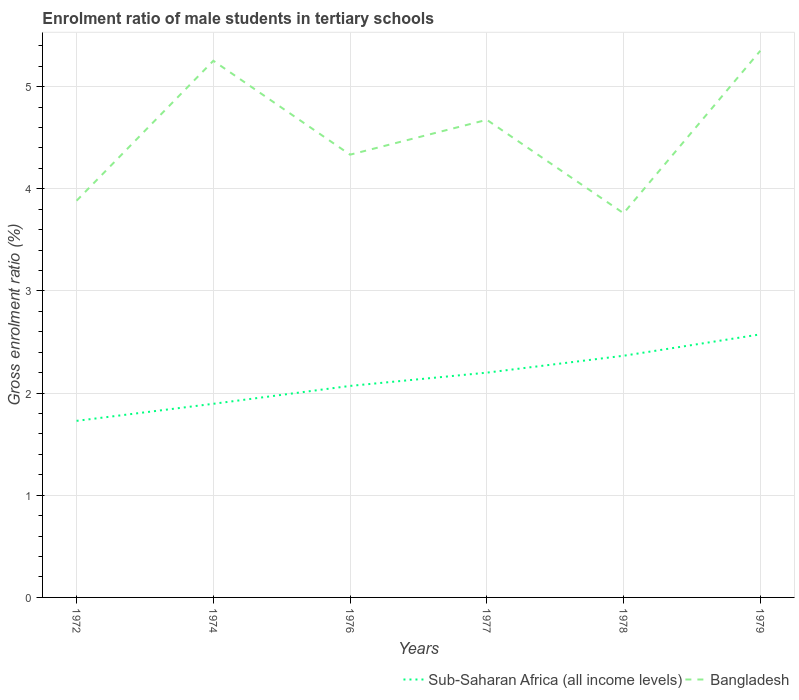How many different coloured lines are there?
Your response must be concise. 2. Is the number of lines equal to the number of legend labels?
Your answer should be very brief. Yes. Across all years, what is the maximum enrolment ratio of male students in tertiary schools in Bangladesh?
Your answer should be compact. 3.76. In which year was the enrolment ratio of male students in tertiary schools in Bangladesh maximum?
Your response must be concise. 1978. What is the total enrolment ratio of male students in tertiary schools in Bangladesh in the graph?
Give a very brief answer. -1.59. What is the difference between the highest and the second highest enrolment ratio of male students in tertiary schools in Sub-Saharan Africa (all income levels)?
Provide a succinct answer. 0.85. Is the enrolment ratio of male students in tertiary schools in Bangladesh strictly greater than the enrolment ratio of male students in tertiary schools in Sub-Saharan Africa (all income levels) over the years?
Give a very brief answer. No. Does the graph contain any zero values?
Offer a terse response. No. Does the graph contain grids?
Provide a short and direct response. Yes. Where does the legend appear in the graph?
Make the answer very short. Bottom right. How are the legend labels stacked?
Give a very brief answer. Horizontal. What is the title of the graph?
Ensure brevity in your answer.  Enrolment ratio of male students in tertiary schools. Does "Jamaica" appear as one of the legend labels in the graph?
Give a very brief answer. No. What is the label or title of the X-axis?
Ensure brevity in your answer.  Years. What is the label or title of the Y-axis?
Keep it short and to the point. Gross enrolment ratio (%). What is the Gross enrolment ratio (%) of Sub-Saharan Africa (all income levels) in 1972?
Your answer should be very brief. 1.73. What is the Gross enrolment ratio (%) of Bangladesh in 1972?
Your answer should be very brief. 3.88. What is the Gross enrolment ratio (%) in Sub-Saharan Africa (all income levels) in 1974?
Provide a short and direct response. 1.9. What is the Gross enrolment ratio (%) of Bangladesh in 1974?
Make the answer very short. 5.25. What is the Gross enrolment ratio (%) of Sub-Saharan Africa (all income levels) in 1976?
Ensure brevity in your answer.  2.07. What is the Gross enrolment ratio (%) of Bangladesh in 1976?
Your answer should be very brief. 4.33. What is the Gross enrolment ratio (%) of Sub-Saharan Africa (all income levels) in 1977?
Ensure brevity in your answer.  2.2. What is the Gross enrolment ratio (%) in Bangladesh in 1977?
Your response must be concise. 4.68. What is the Gross enrolment ratio (%) in Sub-Saharan Africa (all income levels) in 1978?
Your answer should be compact. 2.37. What is the Gross enrolment ratio (%) in Bangladesh in 1978?
Ensure brevity in your answer.  3.76. What is the Gross enrolment ratio (%) in Sub-Saharan Africa (all income levels) in 1979?
Provide a succinct answer. 2.58. What is the Gross enrolment ratio (%) in Bangladesh in 1979?
Give a very brief answer. 5.35. Across all years, what is the maximum Gross enrolment ratio (%) in Sub-Saharan Africa (all income levels)?
Your response must be concise. 2.58. Across all years, what is the maximum Gross enrolment ratio (%) in Bangladesh?
Provide a short and direct response. 5.35. Across all years, what is the minimum Gross enrolment ratio (%) of Sub-Saharan Africa (all income levels)?
Offer a very short reply. 1.73. Across all years, what is the minimum Gross enrolment ratio (%) of Bangladesh?
Your answer should be compact. 3.76. What is the total Gross enrolment ratio (%) in Sub-Saharan Africa (all income levels) in the graph?
Make the answer very short. 12.84. What is the total Gross enrolment ratio (%) of Bangladesh in the graph?
Give a very brief answer. 27.26. What is the difference between the Gross enrolment ratio (%) in Sub-Saharan Africa (all income levels) in 1972 and that in 1974?
Keep it short and to the point. -0.17. What is the difference between the Gross enrolment ratio (%) in Bangladesh in 1972 and that in 1974?
Your answer should be very brief. -1.37. What is the difference between the Gross enrolment ratio (%) in Sub-Saharan Africa (all income levels) in 1972 and that in 1976?
Make the answer very short. -0.34. What is the difference between the Gross enrolment ratio (%) of Bangladesh in 1972 and that in 1976?
Give a very brief answer. -0.45. What is the difference between the Gross enrolment ratio (%) of Sub-Saharan Africa (all income levels) in 1972 and that in 1977?
Provide a short and direct response. -0.47. What is the difference between the Gross enrolment ratio (%) in Bangladesh in 1972 and that in 1977?
Provide a succinct answer. -0.79. What is the difference between the Gross enrolment ratio (%) of Sub-Saharan Africa (all income levels) in 1972 and that in 1978?
Offer a very short reply. -0.64. What is the difference between the Gross enrolment ratio (%) in Bangladesh in 1972 and that in 1978?
Offer a very short reply. 0.12. What is the difference between the Gross enrolment ratio (%) in Sub-Saharan Africa (all income levels) in 1972 and that in 1979?
Your answer should be very brief. -0.85. What is the difference between the Gross enrolment ratio (%) of Bangladesh in 1972 and that in 1979?
Give a very brief answer. -1.47. What is the difference between the Gross enrolment ratio (%) in Sub-Saharan Africa (all income levels) in 1974 and that in 1976?
Ensure brevity in your answer.  -0.17. What is the difference between the Gross enrolment ratio (%) of Bangladesh in 1974 and that in 1976?
Offer a terse response. 0.92. What is the difference between the Gross enrolment ratio (%) in Sub-Saharan Africa (all income levels) in 1974 and that in 1977?
Your answer should be compact. -0.3. What is the difference between the Gross enrolment ratio (%) in Bangladesh in 1974 and that in 1977?
Provide a short and direct response. 0.58. What is the difference between the Gross enrolment ratio (%) in Sub-Saharan Africa (all income levels) in 1974 and that in 1978?
Your response must be concise. -0.47. What is the difference between the Gross enrolment ratio (%) of Bangladesh in 1974 and that in 1978?
Your answer should be very brief. 1.49. What is the difference between the Gross enrolment ratio (%) in Sub-Saharan Africa (all income levels) in 1974 and that in 1979?
Your answer should be very brief. -0.68. What is the difference between the Gross enrolment ratio (%) in Bangladesh in 1974 and that in 1979?
Offer a terse response. -0.1. What is the difference between the Gross enrolment ratio (%) of Sub-Saharan Africa (all income levels) in 1976 and that in 1977?
Offer a very short reply. -0.13. What is the difference between the Gross enrolment ratio (%) of Bangladesh in 1976 and that in 1977?
Offer a very short reply. -0.34. What is the difference between the Gross enrolment ratio (%) in Sub-Saharan Africa (all income levels) in 1976 and that in 1978?
Provide a succinct answer. -0.3. What is the difference between the Gross enrolment ratio (%) of Bangladesh in 1976 and that in 1978?
Your answer should be very brief. 0.57. What is the difference between the Gross enrolment ratio (%) in Sub-Saharan Africa (all income levels) in 1976 and that in 1979?
Give a very brief answer. -0.5. What is the difference between the Gross enrolment ratio (%) in Bangladesh in 1976 and that in 1979?
Your answer should be very brief. -1.02. What is the difference between the Gross enrolment ratio (%) of Sub-Saharan Africa (all income levels) in 1977 and that in 1978?
Your response must be concise. -0.17. What is the difference between the Gross enrolment ratio (%) of Bangladesh in 1977 and that in 1978?
Your answer should be very brief. 0.91. What is the difference between the Gross enrolment ratio (%) of Sub-Saharan Africa (all income levels) in 1977 and that in 1979?
Give a very brief answer. -0.37. What is the difference between the Gross enrolment ratio (%) of Bangladesh in 1977 and that in 1979?
Keep it short and to the point. -0.68. What is the difference between the Gross enrolment ratio (%) in Sub-Saharan Africa (all income levels) in 1978 and that in 1979?
Offer a terse response. -0.21. What is the difference between the Gross enrolment ratio (%) of Bangladesh in 1978 and that in 1979?
Give a very brief answer. -1.59. What is the difference between the Gross enrolment ratio (%) in Sub-Saharan Africa (all income levels) in 1972 and the Gross enrolment ratio (%) in Bangladesh in 1974?
Your answer should be compact. -3.52. What is the difference between the Gross enrolment ratio (%) in Sub-Saharan Africa (all income levels) in 1972 and the Gross enrolment ratio (%) in Bangladesh in 1976?
Keep it short and to the point. -2.61. What is the difference between the Gross enrolment ratio (%) in Sub-Saharan Africa (all income levels) in 1972 and the Gross enrolment ratio (%) in Bangladesh in 1977?
Offer a terse response. -2.95. What is the difference between the Gross enrolment ratio (%) in Sub-Saharan Africa (all income levels) in 1972 and the Gross enrolment ratio (%) in Bangladesh in 1978?
Offer a very short reply. -2.03. What is the difference between the Gross enrolment ratio (%) in Sub-Saharan Africa (all income levels) in 1972 and the Gross enrolment ratio (%) in Bangladesh in 1979?
Provide a succinct answer. -3.62. What is the difference between the Gross enrolment ratio (%) in Sub-Saharan Africa (all income levels) in 1974 and the Gross enrolment ratio (%) in Bangladesh in 1976?
Ensure brevity in your answer.  -2.44. What is the difference between the Gross enrolment ratio (%) of Sub-Saharan Africa (all income levels) in 1974 and the Gross enrolment ratio (%) of Bangladesh in 1977?
Make the answer very short. -2.78. What is the difference between the Gross enrolment ratio (%) of Sub-Saharan Africa (all income levels) in 1974 and the Gross enrolment ratio (%) of Bangladesh in 1978?
Your response must be concise. -1.87. What is the difference between the Gross enrolment ratio (%) in Sub-Saharan Africa (all income levels) in 1974 and the Gross enrolment ratio (%) in Bangladesh in 1979?
Provide a short and direct response. -3.46. What is the difference between the Gross enrolment ratio (%) of Sub-Saharan Africa (all income levels) in 1976 and the Gross enrolment ratio (%) of Bangladesh in 1977?
Ensure brevity in your answer.  -2.6. What is the difference between the Gross enrolment ratio (%) in Sub-Saharan Africa (all income levels) in 1976 and the Gross enrolment ratio (%) in Bangladesh in 1978?
Give a very brief answer. -1.69. What is the difference between the Gross enrolment ratio (%) in Sub-Saharan Africa (all income levels) in 1976 and the Gross enrolment ratio (%) in Bangladesh in 1979?
Give a very brief answer. -3.28. What is the difference between the Gross enrolment ratio (%) of Sub-Saharan Africa (all income levels) in 1977 and the Gross enrolment ratio (%) of Bangladesh in 1978?
Your answer should be very brief. -1.56. What is the difference between the Gross enrolment ratio (%) in Sub-Saharan Africa (all income levels) in 1977 and the Gross enrolment ratio (%) in Bangladesh in 1979?
Provide a short and direct response. -3.15. What is the difference between the Gross enrolment ratio (%) of Sub-Saharan Africa (all income levels) in 1978 and the Gross enrolment ratio (%) of Bangladesh in 1979?
Your answer should be compact. -2.99. What is the average Gross enrolment ratio (%) of Sub-Saharan Africa (all income levels) per year?
Your answer should be very brief. 2.14. What is the average Gross enrolment ratio (%) of Bangladesh per year?
Make the answer very short. 4.54. In the year 1972, what is the difference between the Gross enrolment ratio (%) in Sub-Saharan Africa (all income levels) and Gross enrolment ratio (%) in Bangladesh?
Offer a very short reply. -2.16. In the year 1974, what is the difference between the Gross enrolment ratio (%) in Sub-Saharan Africa (all income levels) and Gross enrolment ratio (%) in Bangladesh?
Make the answer very short. -3.36. In the year 1976, what is the difference between the Gross enrolment ratio (%) in Sub-Saharan Africa (all income levels) and Gross enrolment ratio (%) in Bangladesh?
Offer a terse response. -2.26. In the year 1977, what is the difference between the Gross enrolment ratio (%) of Sub-Saharan Africa (all income levels) and Gross enrolment ratio (%) of Bangladesh?
Keep it short and to the point. -2.48. In the year 1978, what is the difference between the Gross enrolment ratio (%) of Sub-Saharan Africa (all income levels) and Gross enrolment ratio (%) of Bangladesh?
Offer a very short reply. -1.4. In the year 1979, what is the difference between the Gross enrolment ratio (%) in Sub-Saharan Africa (all income levels) and Gross enrolment ratio (%) in Bangladesh?
Your answer should be compact. -2.78. What is the ratio of the Gross enrolment ratio (%) of Sub-Saharan Africa (all income levels) in 1972 to that in 1974?
Offer a terse response. 0.91. What is the ratio of the Gross enrolment ratio (%) in Bangladesh in 1972 to that in 1974?
Your answer should be compact. 0.74. What is the ratio of the Gross enrolment ratio (%) of Sub-Saharan Africa (all income levels) in 1972 to that in 1976?
Your answer should be compact. 0.83. What is the ratio of the Gross enrolment ratio (%) of Bangladesh in 1972 to that in 1976?
Keep it short and to the point. 0.9. What is the ratio of the Gross enrolment ratio (%) of Sub-Saharan Africa (all income levels) in 1972 to that in 1977?
Offer a very short reply. 0.79. What is the ratio of the Gross enrolment ratio (%) in Bangladesh in 1972 to that in 1977?
Make the answer very short. 0.83. What is the ratio of the Gross enrolment ratio (%) in Sub-Saharan Africa (all income levels) in 1972 to that in 1978?
Provide a succinct answer. 0.73. What is the ratio of the Gross enrolment ratio (%) of Bangladesh in 1972 to that in 1978?
Keep it short and to the point. 1.03. What is the ratio of the Gross enrolment ratio (%) in Sub-Saharan Africa (all income levels) in 1972 to that in 1979?
Your response must be concise. 0.67. What is the ratio of the Gross enrolment ratio (%) in Bangladesh in 1972 to that in 1979?
Provide a short and direct response. 0.73. What is the ratio of the Gross enrolment ratio (%) of Sub-Saharan Africa (all income levels) in 1974 to that in 1976?
Your answer should be compact. 0.92. What is the ratio of the Gross enrolment ratio (%) in Bangladesh in 1974 to that in 1976?
Offer a very short reply. 1.21. What is the ratio of the Gross enrolment ratio (%) in Sub-Saharan Africa (all income levels) in 1974 to that in 1977?
Give a very brief answer. 0.86. What is the ratio of the Gross enrolment ratio (%) in Bangladesh in 1974 to that in 1977?
Give a very brief answer. 1.12. What is the ratio of the Gross enrolment ratio (%) of Sub-Saharan Africa (all income levels) in 1974 to that in 1978?
Keep it short and to the point. 0.8. What is the ratio of the Gross enrolment ratio (%) of Bangladesh in 1974 to that in 1978?
Offer a terse response. 1.4. What is the ratio of the Gross enrolment ratio (%) of Sub-Saharan Africa (all income levels) in 1974 to that in 1979?
Make the answer very short. 0.74. What is the ratio of the Gross enrolment ratio (%) in Bangladesh in 1974 to that in 1979?
Your answer should be very brief. 0.98. What is the ratio of the Gross enrolment ratio (%) of Sub-Saharan Africa (all income levels) in 1976 to that in 1977?
Offer a terse response. 0.94. What is the ratio of the Gross enrolment ratio (%) of Bangladesh in 1976 to that in 1977?
Ensure brevity in your answer.  0.93. What is the ratio of the Gross enrolment ratio (%) of Sub-Saharan Africa (all income levels) in 1976 to that in 1978?
Provide a short and direct response. 0.88. What is the ratio of the Gross enrolment ratio (%) in Bangladesh in 1976 to that in 1978?
Provide a short and direct response. 1.15. What is the ratio of the Gross enrolment ratio (%) in Sub-Saharan Africa (all income levels) in 1976 to that in 1979?
Keep it short and to the point. 0.8. What is the ratio of the Gross enrolment ratio (%) in Bangladesh in 1976 to that in 1979?
Offer a terse response. 0.81. What is the ratio of the Gross enrolment ratio (%) of Sub-Saharan Africa (all income levels) in 1977 to that in 1978?
Ensure brevity in your answer.  0.93. What is the ratio of the Gross enrolment ratio (%) of Bangladesh in 1977 to that in 1978?
Offer a very short reply. 1.24. What is the ratio of the Gross enrolment ratio (%) in Sub-Saharan Africa (all income levels) in 1977 to that in 1979?
Your answer should be compact. 0.85. What is the ratio of the Gross enrolment ratio (%) in Bangladesh in 1977 to that in 1979?
Ensure brevity in your answer.  0.87. What is the ratio of the Gross enrolment ratio (%) in Sub-Saharan Africa (all income levels) in 1978 to that in 1979?
Offer a terse response. 0.92. What is the ratio of the Gross enrolment ratio (%) in Bangladesh in 1978 to that in 1979?
Your answer should be compact. 0.7. What is the difference between the highest and the second highest Gross enrolment ratio (%) in Sub-Saharan Africa (all income levels)?
Provide a succinct answer. 0.21. What is the difference between the highest and the second highest Gross enrolment ratio (%) of Bangladesh?
Your answer should be very brief. 0.1. What is the difference between the highest and the lowest Gross enrolment ratio (%) of Sub-Saharan Africa (all income levels)?
Give a very brief answer. 0.85. What is the difference between the highest and the lowest Gross enrolment ratio (%) in Bangladesh?
Offer a terse response. 1.59. 